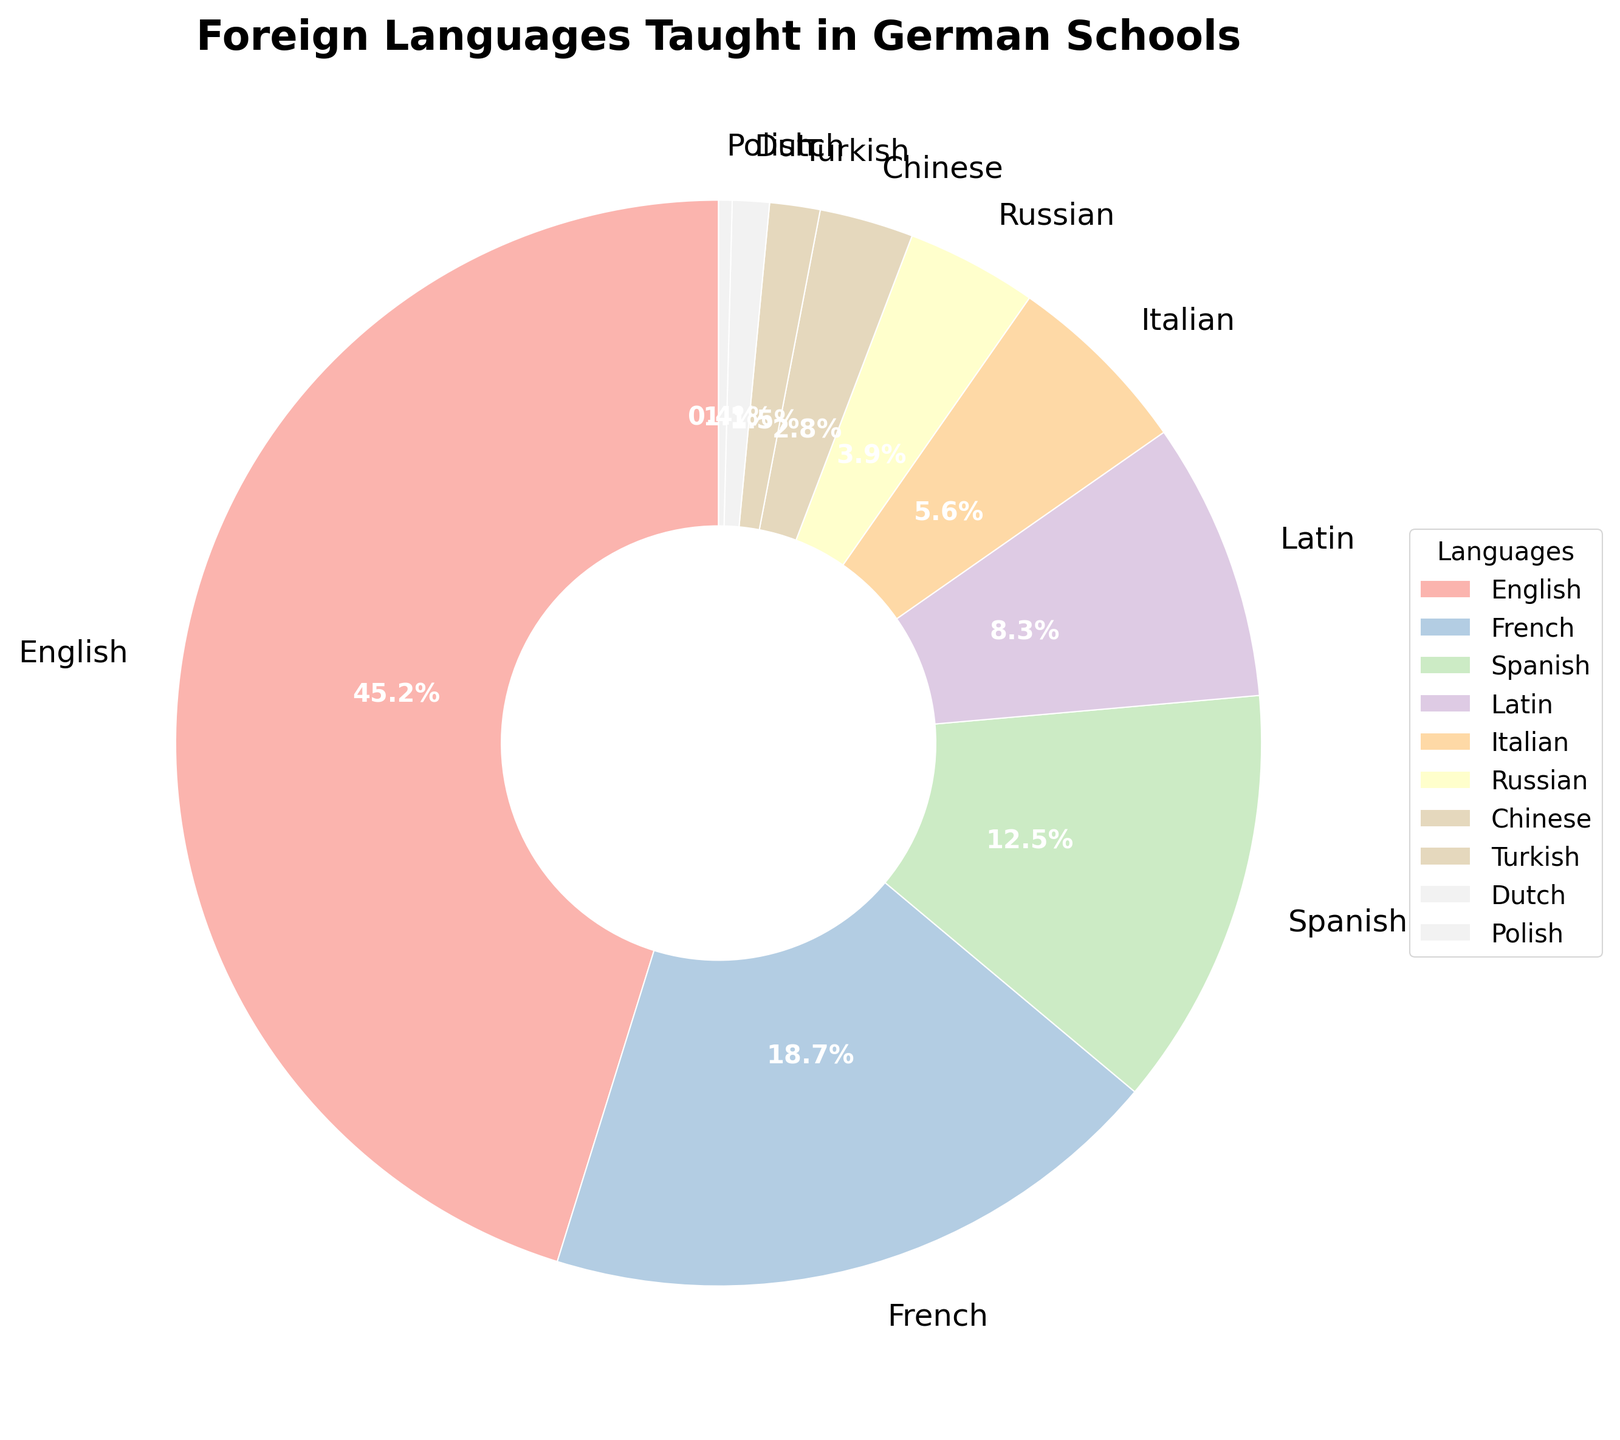Which language has the highest percentage of being taught in German schools? By looking at the pie chart, the segment that is the largest represents the language with the highest percentage. The label on this segment shows it is English with 45.2%.
Answer: English Which two languages combined have a higher percentage than French? French is taught at 18.7%. Looking at the chart, Spanish (12.5%) and Latin (8.3%) together make 20.8%, which is higher than French.
Answer: Spanish and Latin What is the difference in percentage between the most and least taught languages? The most taught language is English at 45.2%, and the least taught language is Polish at 0.4%. Subtracting these percentages gives 45.2% - 0.4% = 44.8%.
Answer: 44.8% What is the total percentage of students learning Romance languages (French, Spanish, Italian, Latin)? The percentages are French (18.7%), Spanish (12.5%), Italian (5.6%), and Latin (8.3%). Adding these gives 18.7% + 12.5% + 5.6% + 8.3% = 45.1%.
Answer: 45.1% Which language taught in German schools has the exact same percentage as the percentage difference between French and Spanish? The difference between French (18.7%) and Spanish (12.5%) is 18.7% - 12.5% = 6.2%. No language matches this percentage exactly.
Answer: None Is Latin more commonly taught than Russian? By checking the pie chart, Latin has a percentage of 8.3%, and Russian has 3.9%, so Latin is more commonly taught than Russian.
Answer: Yes Align the languages in descending order based on their percentage. What is the fourth language on the list? Sorting the languages: English (45.2%), French (18.7%), Spanish (12.5%), Latin (8.3%). The fourth language in descending order is Latin.
Answer: Latin If a class has 1000 students, how many students are likely to be learning Chinese based on the percentages? Chinese is taught to 2.8% of students. Therefore, in a class of 1000, the number would be 1000 * (2.8 / 100) = 28 students.
Answer: 28 